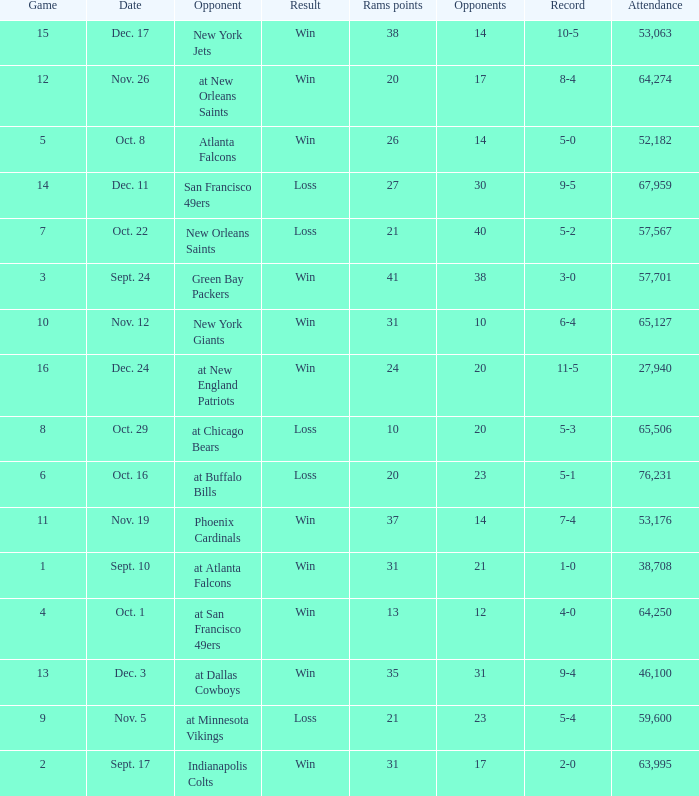What was the attendance where the record was 8-4? 64274.0. 